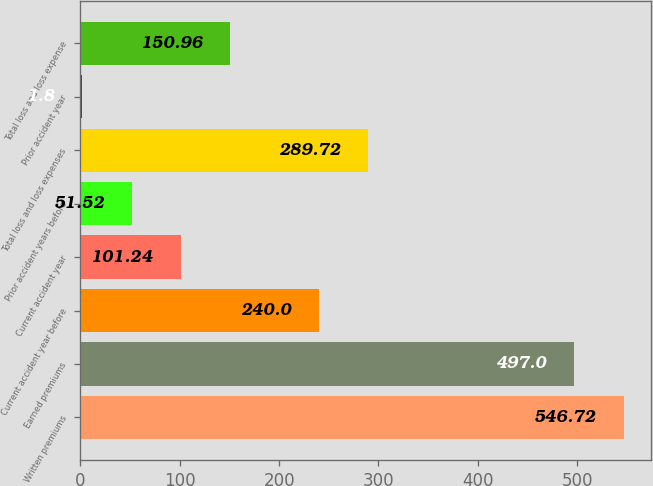Convert chart. <chart><loc_0><loc_0><loc_500><loc_500><bar_chart><fcel>Written premiums<fcel>Earned premiums<fcel>Current accident year before<fcel>Current accident year<fcel>Prior accident years before<fcel>Total loss and loss expenses<fcel>Prior accident year<fcel>Total loss and loss expense<nl><fcel>546.72<fcel>497<fcel>240<fcel>101.24<fcel>51.52<fcel>289.72<fcel>1.8<fcel>150.96<nl></chart> 